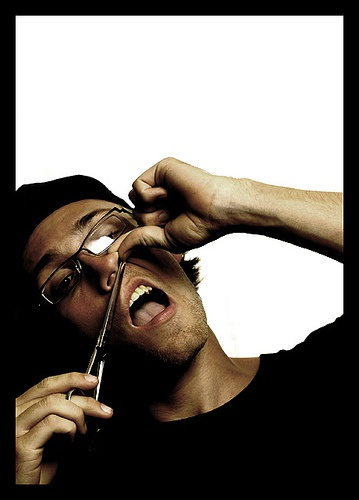Describe the objects in this image and their specific colors. I can see people in black, maroon, and tan tones and scissors in black, maroon, and tan tones in this image. 